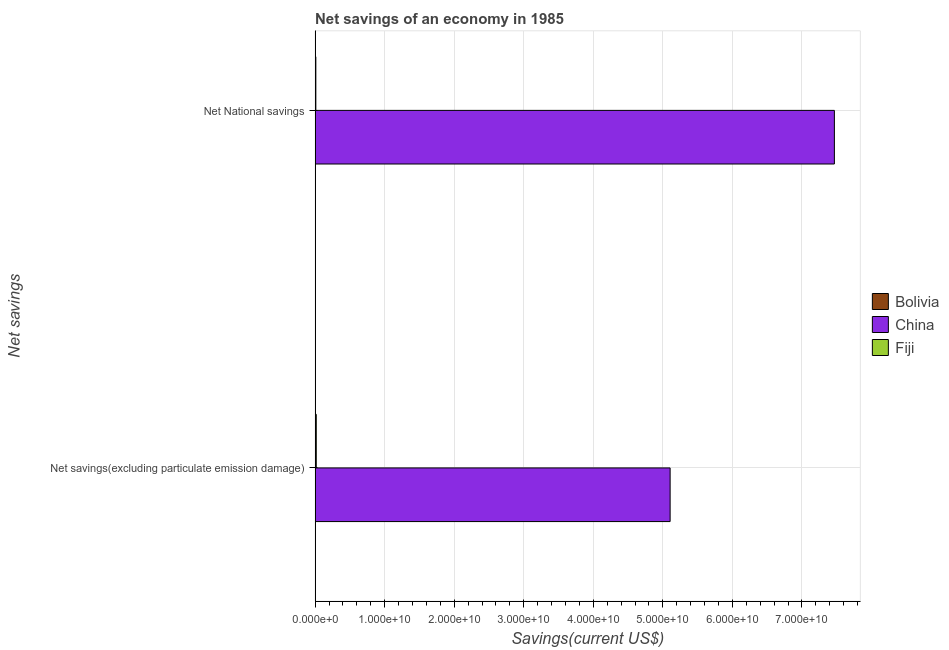How many bars are there on the 1st tick from the bottom?
Provide a short and direct response. 2. What is the label of the 1st group of bars from the top?
Your answer should be very brief. Net National savings. What is the net national savings in China?
Your response must be concise. 7.47e+1. Across all countries, what is the maximum net national savings?
Keep it short and to the point. 7.47e+1. Across all countries, what is the minimum net national savings?
Provide a short and direct response. 3.72e+07. What is the total net national savings in the graph?
Ensure brevity in your answer.  7.48e+1. What is the difference between the net national savings in Bolivia and that in Fiji?
Give a very brief answer. -6.94e+07. What is the difference between the net savings(excluding particulate emission damage) in Fiji and the net national savings in Bolivia?
Your answer should be compact. 1.30e+08. What is the average net national savings per country?
Provide a succinct answer. 2.49e+1. What is the difference between the net savings(excluding particulate emission damage) and net national savings in Fiji?
Make the answer very short. 6.07e+07. In how many countries, is the net national savings greater than 6000000000 US$?
Ensure brevity in your answer.  1. What is the ratio of the net savings(excluding particulate emission damage) in China to that in Fiji?
Provide a short and direct response. 305.04. Is the net savings(excluding particulate emission damage) in Fiji less than that in China?
Your response must be concise. Yes. Are all the bars in the graph horizontal?
Keep it short and to the point. Yes. How many countries are there in the graph?
Give a very brief answer. 3. Does the graph contain any zero values?
Make the answer very short. Yes. Does the graph contain grids?
Make the answer very short. Yes. How are the legend labels stacked?
Keep it short and to the point. Vertical. What is the title of the graph?
Offer a very short reply. Net savings of an economy in 1985. Does "Middle income" appear as one of the legend labels in the graph?
Keep it short and to the point. No. What is the label or title of the X-axis?
Ensure brevity in your answer.  Savings(current US$). What is the label or title of the Y-axis?
Make the answer very short. Net savings. What is the Savings(current US$) of Bolivia in Net savings(excluding particulate emission damage)?
Your response must be concise. 0. What is the Savings(current US$) of China in Net savings(excluding particulate emission damage)?
Make the answer very short. 5.10e+1. What is the Savings(current US$) in Fiji in Net savings(excluding particulate emission damage)?
Make the answer very short. 1.67e+08. What is the Savings(current US$) in Bolivia in Net National savings?
Ensure brevity in your answer.  3.72e+07. What is the Savings(current US$) of China in Net National savings?
Make the answer very short. 7.47e+1. What is the Savings(current US$) in Fiji in Net National savings?
Ensure brevity in your answer.  1.07e+08. Across all Net savings, what is the maximum Savings(current US$) of Bolivia?
Give a very brief answer. 3.72e+07. Across all Net savings, what is the maximum Savings(current US$) of China?
Your response must be concise. 7.47e+1. Across all Net savings, what is the maximum Savings(current US$) of Fiji?
Ensure brevity in your answer.  1.67e+08. Across all Net savings, what is the minimum Savings(current US$) of China?
Give a very brief answer. 5.10e+1. Across all Net savings, what is the minimum Savings(current US$) of Fiji?
Offer a very short reply. 1.07e+08. What is the total Savings(current US$) of Bolivia in the graph?
Your answer should be compact. 3.72e+07. What is the total Savings(current US$) of China in the graph?
Provide a short and direct response. 1.26e+11. What is the total Savings(current US$) of Fiji in the graph?
Give a very brief answer. 2.74e+08. What is the difference between the Savings(current US$) in China in Net savings(excluding particulate emission damage) and that in Net National savings?
Your answer should be compact. -2.36e+1. What is the difference between the Savings(current US$) of Fiji in Net savings(excluding particulate emission damage) and that in Net National savings?
Your response must be concise. 6.07e+07. What is the difference between the Savings(current US$) in China in Net savings(excluding particulate emission damage) and the Savings(current US$) in Fiji in Net National savings?
Your answer should be compact. 5.09e+1. What is the average Savings(current US$) in Bolivia per Net savings?
Give a very brief answer. 1.86e+07. What is the average Savings(current US$) of China per Net savings?
Offer a terse response. 6.29e+1. What is the average Savings(current US$) in Fiji per Net savings?
Your answer should be very brief. 1.37e+08. What is the difference between the Savings(current US$) of China and Savings(current US$) of Fiji in Net savings(excluding particulate emission damage)?
Provide a short and direct response. 5.09e+1. What is the difference between the Savings(current US$) in Bolivia and Savings(current US$) in China in Net National savings?
Provide a succinct answer. -7.46e+1. What is the difference between the Savings(current US$) of Bolivia and Savings(current US$) of Fiji in Net National savings?
Offer a terse response. -6.94e+07. What is the difference between the Savings(current US$) of China and Savings(current US$) of Fiji in Net National savings?
Keep it short and to the point. 7.46e+1. What is the ratio of the Savings(current US$) of China in Net savings(excluding particulate emission damage) to that in Net National savings?
Ensure brevity in your answer.  0.68. What is the ratio of the Savings(current US$) of Fiji in Net savings(excluding particulate emission damage) to that in Net National savings?
Keep it short and to the point. 1.57. What is the difference between the highest and the second highest Savings(current US$) of China?
Offer a very short reply. 2.36e+1. What is the difference between the highest and the second highest Savings(current US$) of Fiji?
Offer a very short reply. 6.07e+07. What is the difference between the highest and the lowest Savings(current US$) of Bolivia?
Offer a terse response. 3.72e+07. What is the difference between the highest and the lowest Savings(current US$) of China?
Ensure brevity in your answer.  2.36e+1. What is the difference between the highest and the lowest Savings(current US$) in Fiji?
Provide a succinct answer. 6.07e+07. 